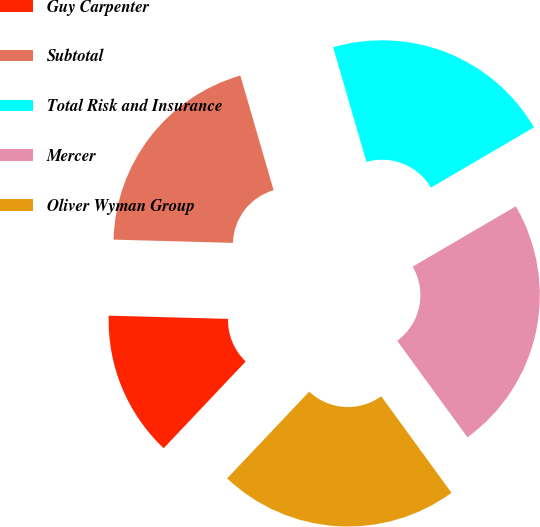Convert chart to OTSL. <chart><loc_0><loc_0><loc_500><loc_500><pie_chart><fcel>Guy Carpenter<fcel>Subtotal<fcel>Total Risk and Insurance<fcel>Mercer<fcel>Oliver Wyman Group<nl><fcel>13.38%<fcel>20.07%<fcel>21.07%<fcel>23.41%<fcel>22.07%<nl></chart> 